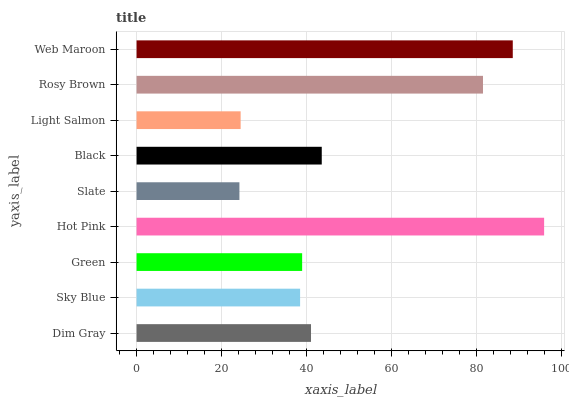Is Slate the minimum?
Answer yes or no. Yes. Is Hot Pink the maximum?
Answer yes or no. Yes. Is Sky Blue the minimum?
Answer yes or no. No. Is Sky Blue the maximum?
Answer yes or no. No. Is Dim Gray greater than Sky Blue?
Answer yes or no. Yes. Is Sky Blue less than Dim Gray?
Answer yes or no. Yes. Is Sky Blue greater than Dim Gray?
Answer yes or no. No. Is Dim Gray less than Sky Blue?
Answer yes or no. No. Is Dim Gray the high median?
Answer yes or no. Yes. Is Dim Gray the low median?
Answer yes or no. Yes. Is Hot Pink the high median?
Answer yes or no. No. Is Sky Blue the low median?
Answer yes or no. No. 